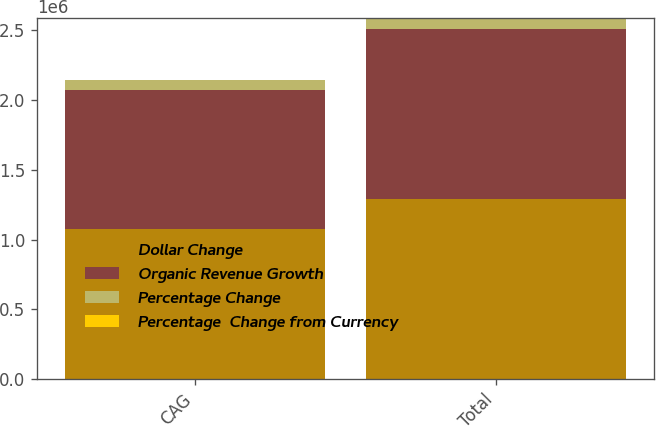Convert chart to OTSL. <chart><loc_0><loc_0><loc_500><loc_500><stacked_bar_chart><ecel><fcel>CAG<fcel>Total<nl><fcel>Dollar Change<fcel>1.07221e+06<fcel>1.29334e+06<nl><fcel>Organic Revenue Growth<fcel>999722<fcel>1.21869e+06<nl><fcel>Percentage Change<fcel>72489<fcel>74649<nl><fcel>Percentage  Change from Currency<fcel>7.3<fcel>6.1<nl></chart> 